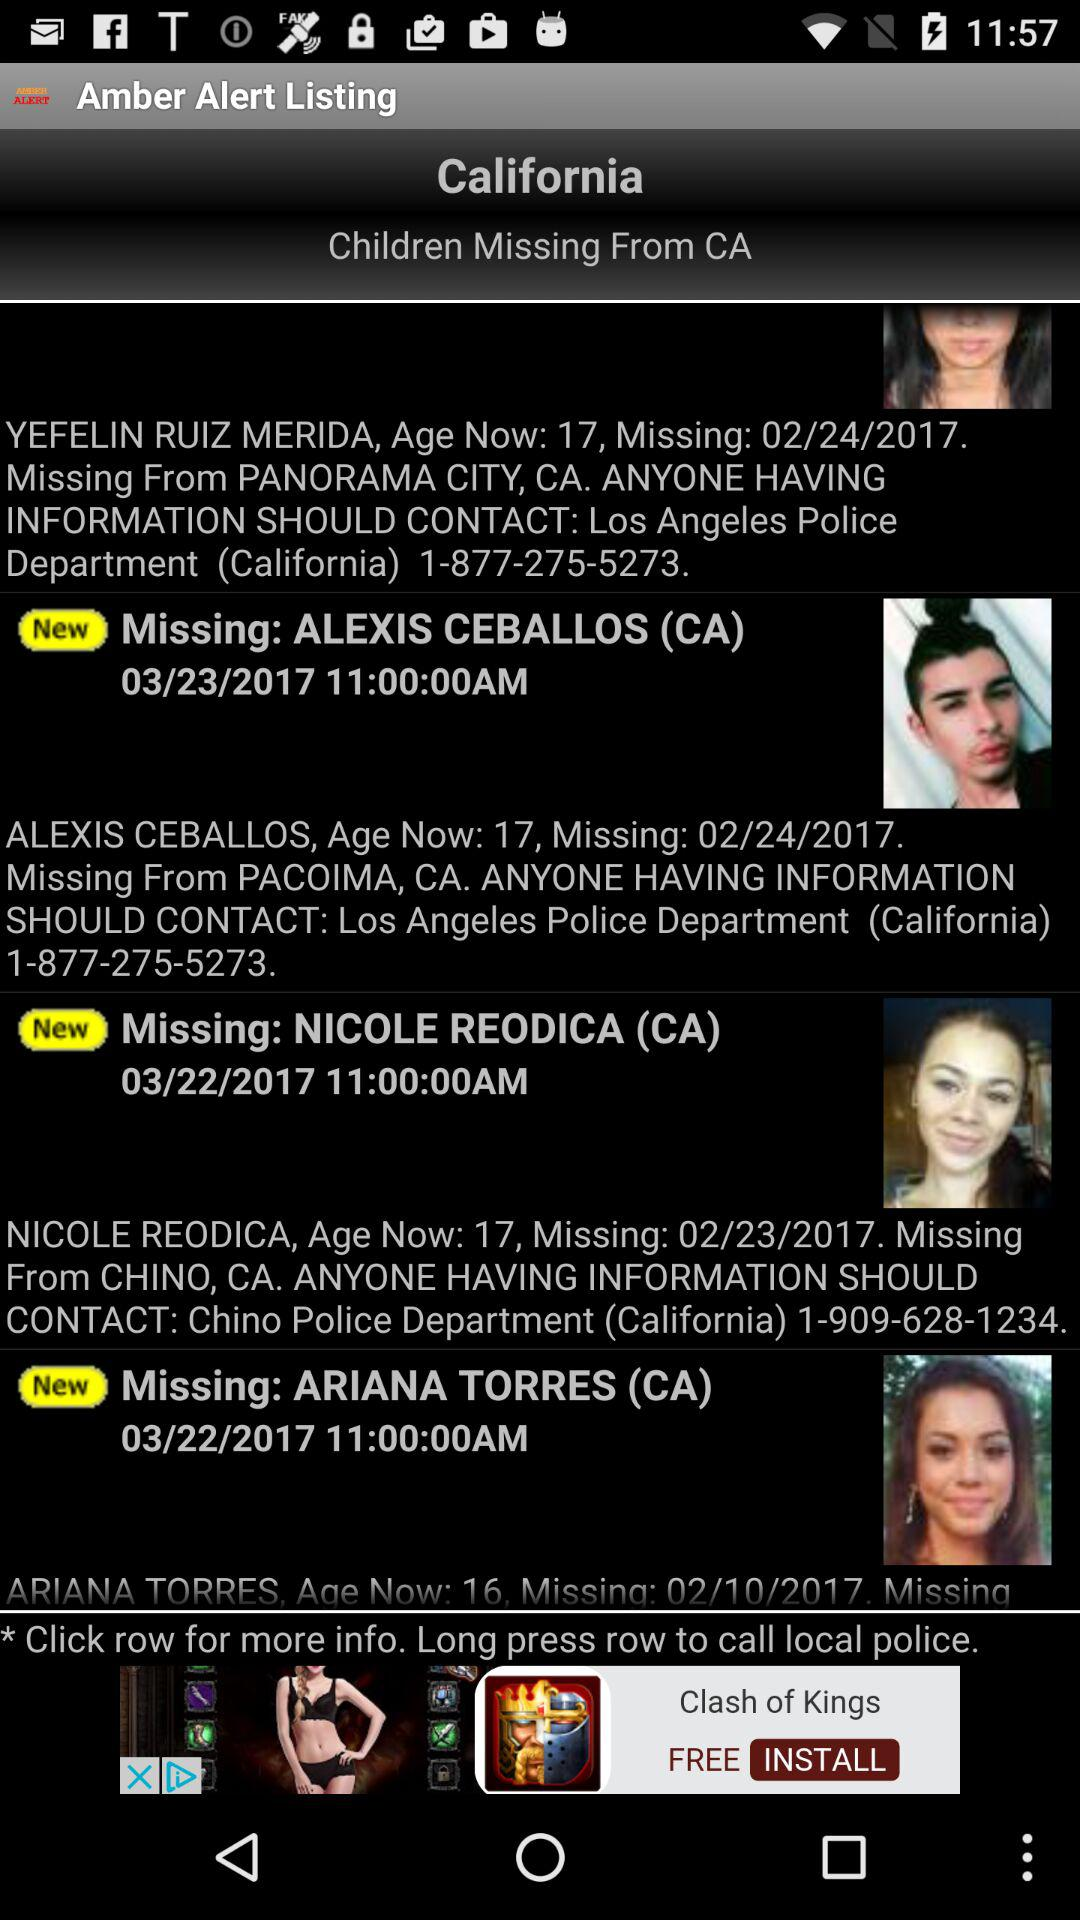When did Alexis Ceballos go missing? Alexis Ceballos went missing on February 24, 2017. 